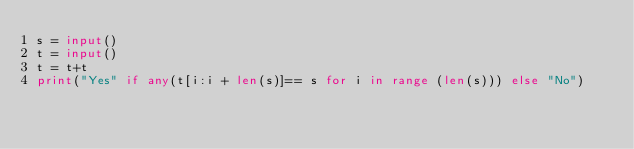Convert code to text. <code><loc_0><loc_0><loc_500><loc_500><_Python_>s = input()
t = input()
t = t+t
print("Yes" if any(t[i:i + len(s)]== s for i in range (len(s))) else "No")</code> 